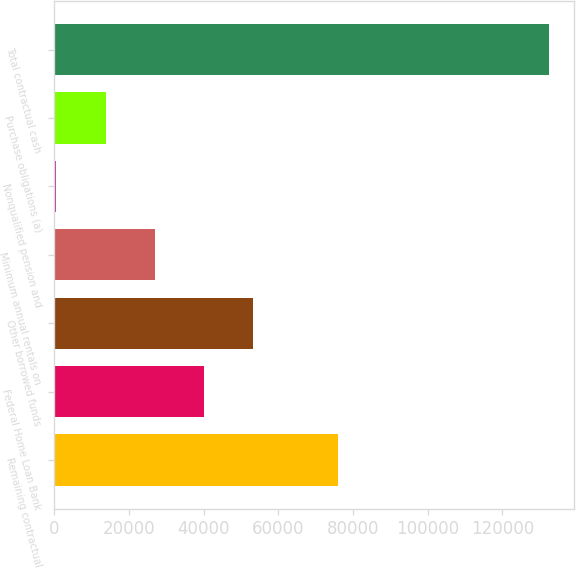Convert chart. <chart><loc_0><loc_0><loc_500><loc_500><bar_chart><fcel>Remaining contractual<fcel>Federal Home Loan Bank<fcel>Other borrowed funds<fcel>Minimum annual rentals on<fcel>Nonqualified pension and<fcel>Purchase obligations (a)<fcel>Total contractual cash<nl><fcel>75919<fcel>40142.7<fcel>53334.6<fcel>26950.8<fcel>567<fcel>13758.9<fcel>132486<nl></chart> 